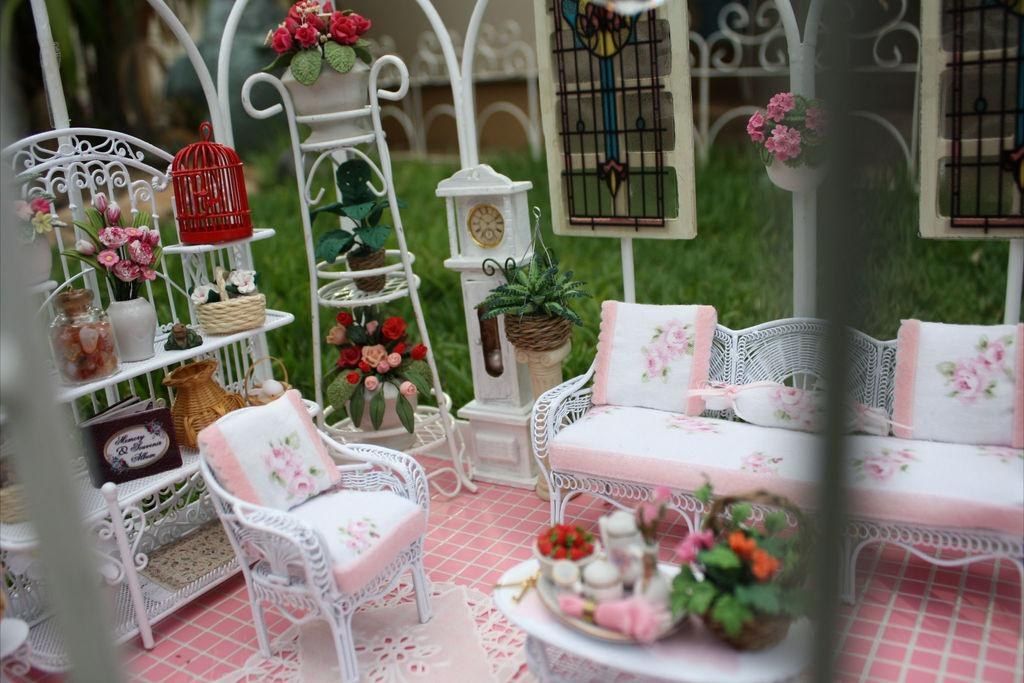What type of furniture is present in the image? There is a couch in the image. What can be seen in the background of the image? There is a wall, a window, and a clock in the background of the image. What is located on the left side of the image? There is a flower pot, a bottle, and a pot on a rack on the left side of the image. What type of corn is growing on the wall in the image? There is no corn present in the image. 